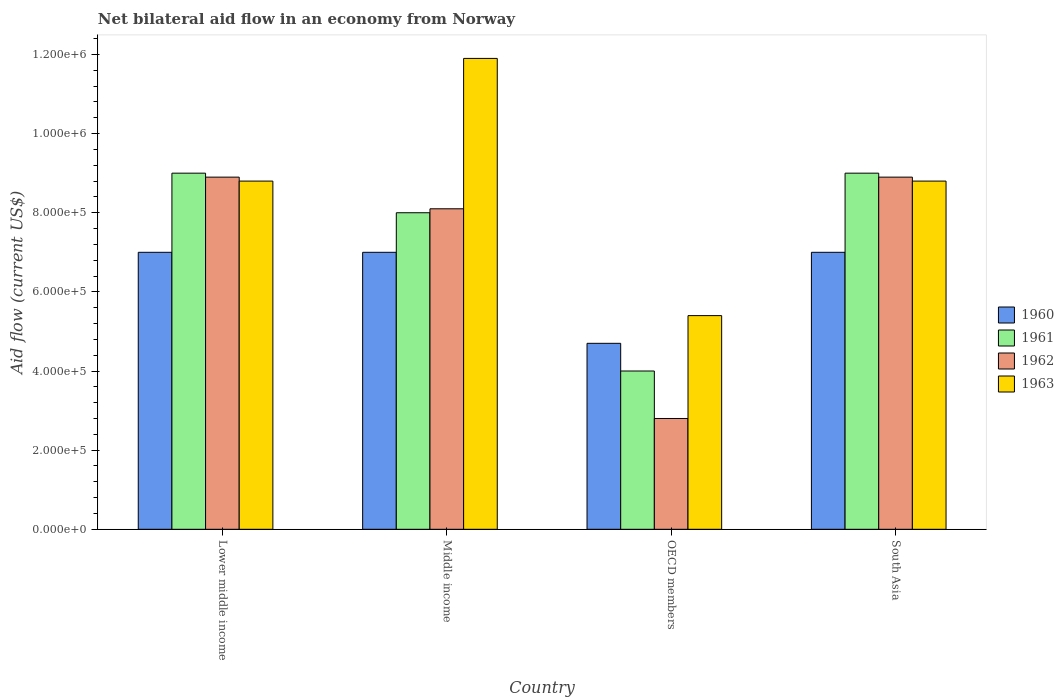How many different coloured bars are there?
Provide a succinct answer. 4. What is the label of the 3rd group of bars from the left?
Make the answer very short. OECD members. What is the net bilateral aid flow in 1962 in South Asia?
Provide a short and direct response. 8.90e+05. Across all countries, what is the maximum net bilateral aid flow in 1963?
Your answer should be very brief. 1.19e+06. In which country was the net bilateral aid flow in 1962 maximum?
Your answer should be very brief. Lower middle income. In which country was the net bilateral aid flow in 1960 minimum?
Your answer should be very brief. OECD members. What is the total net bilateral aid flow in 1962 in the graph?
Your answer should be compact. 2.87e+06. What is the average net bilateral aid flow in 1961 per country?
Give a very brief answer. 7.50e+05. What is the difference between the net bilateral aid flow of/in 1961 and net bilateral aid flow of/in 1963 in South Asia?
Make the answer very short. 2.00e+04. What is the ratio of the net bilateral aid flow in 1960 in Middle income to that in South Asia?
Your answer should be compact. 1. Is the net bilateral aid flow in 1963 in Lower middle income less than that in OECD members?
Your answer should be very brief. No. Is the difference between the net bilateral aid flow in 1961 in OECD members and South Asia greater than the difference between the net bilateral aid flow in 1963 in OECD members and South Asia?
Make the answer very short. No. What is the difference between the highest and the second highest net bilateral aid flow in 1963?
Keep it short and to the point. 3.10e+05. What is the difference between the highest and the lowest net bilateral aid flow in 1961?
Ensure brevity in your answer.  5.00e+05. In how many countries, is the net bilateral aid flow in 1961 greater than the average net bilateral aid flow in 1961 taken over all countries?
Ensure brevity in your answer.  3. What does the 2nd bar from the left in OECD members represents?
Provide a short and direct response. 1961. How many bars are there?
Ensure brevity in your answer.  16. How many countries are there in the graph?
Offer a terse response. 4. What is the difference between two consecutive major ticks on the Y-axis?
Ensure brevity in your answer.  2.00e+05. Are the values on the major ticks of Y-axis written in scientific E-notation?
Give a very brief answer. Yes. Does the graph contain any zero values?
Keep it short and to the point. No. How many legend labels are there?
Your response must be concise. 4. How are the legend labels stacked?
Your response must be concise. Vertical. What is the title of the graph?
Give a very brief answer. Net bilateral aid flow in an economy from Norway. What is the label or title of the Y-axis?
Keep it short and to the point. Aid flow (current US$). What is the Aid flow (current US$) in 1960 in Lower middle income?
Give a very brief answer. 7.00e+05. What is the Aid flow (current US$) of 1961 in Lower middle income?
Your answer should be compact. 9.00e+05. What is the Aid flow (current US$) in 1962 in Lower middle income?
Your response must be concise. 8.90e+05. What is the Aid flow (current US$) of 1963 in Lower middle income?
Your response must be concise. 8.80e+05. What is the Aid flow (current US$) of 1961 in Middle income?
Offer a terse response. 8.00e+05. What is the Aid flow (current US$) of 1962 in Middle income?
Provide a succinct answer. 8.10e+05. What is the Aid flow (current US$) of 1963 in Middle income?
Give a very brief answer. 1.19e+06. What is the Aid flow (current US$) in 1962 in OECD members?
Keep it short and to the point. 2.80e+05. What is the Aid flow (current US$) of 1963 in OECD members?
Provide a succinct answer. 5.40e+05. What is the Aid flow (current US$) of 1960 in South Asia?
Offer a terse response. 7.00e+05. What is the Aid flow (current US$) in 1961 in South Asia?
Provide a short and direct response. 9.00e+05. What is the Aid flow (current US$) of 1962 in South Asia?
Offer a terse response. 8.90e+05. What is the Aid flow (current US$) in 1963 in South Asia?
Provide a succinct answer. 8.80e+05. Across all countries, what is the maximum Aid flow (current US$) of 1962?
Make the answer very short. 8.90e+05. Across all countries, what is the maximum Aid flow (current US$) in 1963?
Keep it short and to the point. 1.19e+06. Across all countries, what is the minimum Aid flow (current US$) of 1960?
Give a very brief answer. 4.70e+05. Across all countries, what is the minimum Aid flow (current US$) in 1963?
Your answer should be compact. 5.40e+05. What is the total Aid flow (current US$) in 1960 in the graph?
Offer a very short reply. 2.57e+06. What is the total Aid flow (current US$) in 1961 in the graph?
Give a very brief answer. 3.00e+06. What is the total Aid flow (current US$) in 1962 in the graph?
Your answer should be very brief. 2.87e+06. What is the total Aid flow (current US$) in 1963 in the graph?
Your answer should be compact. 3.49e+06. What is the difference between the Aid flow (current US$) of 1962 in Lower middle income and that in Middle income?
Your answer should be compact. 8.00e+04. What is the difference between the Aid flow (current US$) of 1963 in Lower middle income and that in Middle income?
Make the answer very short. -3.10e+05. What is the difference between the Aid flow (current US$) of 1961 in Lower middle income and that in OECD members?
Offer a terse response. 5.00e+05. What is the difference between the Aid flow (current US$) of 1961 in Lower middle income and that in South Asia?
Provide a short and direct response. 0. What is the difference between the Aid flow (current US$) in 1963 in Lower middle income and that in South Asia?
Ensure brevity in your answer.  0. What is the difference between the Aid flow (current US$) in 1960 in Middle income and that in OECD members?
Provide a short and direct response. 2.30e+05. What is the difference between the Aid flow (current US$) in 1962 in Middle income and that in OECD members?
Keep it short and to the point. 5.30e+05. What is the difference between the Aid flow (current US$) in 1963 in Middle income and that in OECD members?
Make the answer very short. 6.50e+05. What is the difference between the Aid flow (current US$) in 1960 in Middle income and that in South Asia?
Ensure brevity in your answer.  0. What is the difference between the Aid flow (current US$) of 1961 in Middle income and that in South Asia?
Ensure brevity in your answer.  -1.00e+05. What is the difference between the Aid flow (current US$) of 1961 in OECD members and that in South Asia?
Provide a short and direct response. -5.00e+05. What is the difference between the Aid flow (current US$) in 1962 in OECD members and that in South Asia?
Make the answer very short. -6.10e+05. What is the difference between the Aid flow (current US$) in 1960 in Lower middle income and the Aid flow (current US$) in 1961 in Middle income?
Your answer should be compact. -1.00e+05. What is the difference between the Aid flow (current US$) of 1960 in Lower middle income and the Aid flow (current US$) of 1962 in Middle income?
Offer a very short reply. -1.10e+05. What is the difference between the Aid flow (current US$) in 1960 in Lower middle income and the Aid flow (current US$) in 1963 in Middle income?
Offer a very short reply. -4.90e+05. What is the difference between the Aid flow (current US$) in 1961 in Lower middle income and the Aid flow (current US$) in 1963 in Middle income?
Offer a very short reply. -2.90e+05. What is the difference between the Aid flow (current US$) of 1962 in Lower middle income and the Aid flow (current US$) of 1963 in Middle income?
Provide a succinct answer. -3.00e+05. What is the difference between the Aid flow (current US$) of 1960 in Lower middle income and the Aid flow (current US$) of 1962 in OECD members?
Offer a terse response. 4.20e+05. What is the difference between the Aid flow (current US$) of 1961 in Lower middle income and the Aid flow (current US$) of 1962 in OECD members?
Your answer should be very brief. 6.20e+05. What is the difference between the Aid flow (current US$) in 1960 in Lower middle income and the Aid flow (current US$) in 1961 in South Asia?
Provide a succinct answer. -2.00e+05. What is the difference between the Aid flow (current US$) in 1960 in Lower middle income and the Aid flow (current US$) in 1962 in South Asia?
Give a very brief answer. -1.90e+05. What is the difference between the Aid flow (current US$) in 1960 in Lower middle income and the Aid flow (current US$) in 1963 in South Asia?
Your answer should be compact. -1.80e+05. What is the difference between the Aid flow (current US$) of 1962 in Lower middle income and the Aid flow (current US$) of 1963 in South Asia?
Your answer should be very brief. 10000. What is the difference between the Aid flow (current US$) in 1960 in Middle income and the Aid flow (current US$) in 1961 in OECD members?
Provide a succinct answer. 3.00e+05. What is the difference between the Aid flow (current US$) in 1960 in Middle income and the Aid flow (current US$) in 1962 in OECD members?
Give a very brief answer. 4.20e+05. What is the difference between the Aid flow (current US$) of 1960 in Middle income and the Aid flow (current US$) of 1963 in OECD members?
Your answer should be compact. 1.60e+05. What is the difference between the Aid flow (current US$) of 1961 in Middle income and the Aid flow (current US$) of 1962 in OECD members?
Make the answer very short. 5.20e+05. What is the difference between the Aid flow (current US$) of 1961 in Middle income and the Aid flow (current US$) of 1963 in OECD members?
Give a very brief answer. 2.60e+05. What is the difference between the Aid flow (current US$) of 1960 in Middle income and the Aid flow (current US$) of 1961 in South Asia?
Provide a succinct answer. -2.00e+05. What is the difference between the Aid flow (current US$) in 1960 in Middle income and the Aid flow (current US$) in 1962 in South Asia?
Your answer should be very brief. -1.90e+05. What is the difference between the Aid flow (current US$) in 1961 in Middle income and the Aid flow (current US$) in 1963 in South Asia?
Provide a succinct answer. -8.00e+04. What is the difference between the Aid flow (current US$) of 1960 in OECD members and the Aid flow (current US$) of 1961 in South Asia?
Ensure brevity in your answer.  -4.30e+05. What is the difference between the Aid flow (current US$) of 1960 in OECD members and the Aid flow (current US$) of 1962 in South Asia?
Ensure brevity in your answer.  -4.20e+05. What is the difference between the Aid flow (current US$) in 1960 in OECD members and the Aid flow (current US$) in 1963 in South Asia?
Give a very brief answer. -4.10e+05. What is the difference between the Aid flow (current US$) of 1961 in OECD members and the Aid flow (current US$) of 1962 in South Asia?
Provide a succinct answer. -4.90e+05. What is the difference between the Aid flow (current US$) of 1961 in OECD members and the Aid flow (current US$) of 1963 in South Asia?
Make the answer very short. -4.80e+05. What is the difference between the Aid flow (current US$) of 1962 in OECD members and the Aid flow (current US$) of 1963 in South Asia?
Provide a short and direct response. -6.00e+05. What is the average Aid flow (current US$) in 1960 per country?
Keep it short and to the point. 6.42e+05. What is the average Aid flow (current US$) in 1961 per country?
Make the answer very short. 7.50e+05. What is the average Aid flow (current US$) in 1962 per country?
Offer a very short reply. 7.18e+05. What is the average Aid flow (current US$) in 1963 per country?
Offer a terse response. 8.72e+05. What is the difference between the Aid flow (current US$) of 1960 and Aid flow (current US$) of 1961 in Lower middle income?
Provide a short and direct response. -2.00e+05. What is the difference between the Aid flow (current US$) in 1961 and Aid flow (current US$) in 1962 in Lower middle income?
Give a very brief answer. 10000. What is the difference between the Aid flow (current US$) of 1960 and Aid flow (current US$) of 1961 in Middle income?
Offer a very short reply. -1.00e+05. What is the difference between the Aid flow (current US$) in 1960 and Aid flow (current US$) in 1963 in Middle income?
Provide a succinct answer. -4.90e+05. What is the difference between the Aid flow (current US$) of 1961 and Aid flow (current US$) of 1962 in Middle income?
Offer a terse response. -10000. What is the difference between the Aid flow (current US$) in 1961 and Aid flow (current US$) in 1963 in Middle income?
Provide a succinct answer. -3.90e+05. What is the difference between the Aid flow (current US$) in 1962 and Aid flow (current US$) in 1963 in Middle income?
Your answer should be compact. -3.80e+05. What is the difference between the Aid flow (current US$) in 1960 and Aid flow (current US$) in 1962 in OECD members?
Offer a very short reply. 1.90e+05. What is the difference between the Aid flow (current US$) in 1960 and Aid flow (current US$) in 1963 in OECD members?
Your answer should be very brief. -7.00e+04. What is the difference between the Aid flow (current US$) in 1961 and Aid flow (current US$) in 1963 in OECD members?
Ensure brevity in your answer.  -1.40e+05. What is the difference between the Aid flow (current US$) in 1962 and Aid flow (current US$) in 1963 in OECD members?
Ensure brevity in your answer.  -2.60e+05. What is the difference between the Aid flow (current US$) of 1960 and Aid flow (current US$) of 1961 in South Asia?
Provide a short and direct response. -2.00e+05. What is the difference between the Aid flow (current US$) of 1961 and Aid flow (current US$) of 1963 in South Asia?
Ensure brevity in your answer.  2.00e+04. What is the difference between the Aid flow (current US$) of 1962 and Aid flow (current US$) of 1963 in South Asia?
Ensure brevity in your answer.  10000. What is the ratio of the Aid flow (current US$) in 1961 in Lower middle income to that in Middle income?
Ensure brevity in your answer.  1.12. What is the ratio of the Aid flow (current US$) of 1962 in Lower middle income to that in Middle income?
Make the answer very short. 1.1. What is the ratio of the Aid flow (current US$) of 1963 in Lower middle income to that in Middle income?
Your answer should be compact. 0.74. What is the ratio of the Aid flow (current US$) in 1960 in Lower middle income to that in OECD members?
Offer a terse response. 1.49. What is the ratio of the Aid flow (current US$) in 1961 in Lower middle income to that in OECD members?
Keep it short and to the point. 2.25. What is the ratio of the Aid flow (current US$) of 1962 in Lower middle income to that in OECD members?
Provide a succinct answer. 3.18. What is the ratio of the Aid flow (current US$) of 1963 in Lower middle income to that in OECD members?
Your response must be concise. 1.63. What is the ratio of the Aid flow (current US$) of 1960 in Lower middle income to that in South Asia?
Your answer should be very brief. 1. What is the ratio of the Aid flow (current US$) of 1961 in Lower middle income to that in South Asia?
Offer a very short reply. 1. What is the ratio of the Aid flow (current US$) in 1963 in Lower middle income to that in South Asia?
Keep it short and to the point. 1. What is the ratio of the Aid flow (current US$) in 1960 in Middle income to that in OECD members?
Make the answer very short. 1.49. What is the ratio of the Aid flow (current US$) of 1961 in Middle income to that in OECD members?
Provide a succinct answer. 2. What is the ratio of the Aid flow (current US$) in 1962 in Middle income to that in OECD members?
Make the answer very short. 2.89. What is the ratio of the Aid flow (current US$) in 1963 in Middle income to that in OECD members?
Your answer should be very brief. 2.2. What is the ratio of the Aid flow (current US$) in 1961 in Middle income to that in South Asia?
Your answer should be very brief. 0.89. What is the ratio of the Aid flow (current US$) in 1962 in Middle income to that in South Asia?
Provide a succinct answer. 0.91. What is the ratio of the Aid flow (current US$) in 1963 in Middle income to that in South Asia?
Your answer should be compact. 1.35. What is the ratio of the Aid flow (current US$) of 1960 in OECD members to that in South Asia?
Ensure brevity in your answer.  0.67. What is the ratio of the Aid flow (current US$) of 1961 in OECD members to that in South Asia?
Give a very brief answer. 0.44. What is the ratio of the Aid flow (current US$) of 1962 in OECD members to that in South Asia?
Give a very brief answer. 0.31. What is the ratio of the Aid flow (current US$) in 1963 in OECD members to that in South Asia?
Your answer should be compact. 0.61. What is the difference between the highest and the second highest Aid flow (current US$) of 1960?
Your answer should be compact. 0. What is the difference between the highest and the second highest Aid flow (current US$) of 1961?
Provide a short and direct response. 0. What is the difference between the highest and the second highest Aid flow (current US$) of 1962?
Keep it short and to the point. 0. What is the difference between the highest and the lowest Aid flow (current US$) in 1963?
Keep it short and to the point. 6.50e+05. 